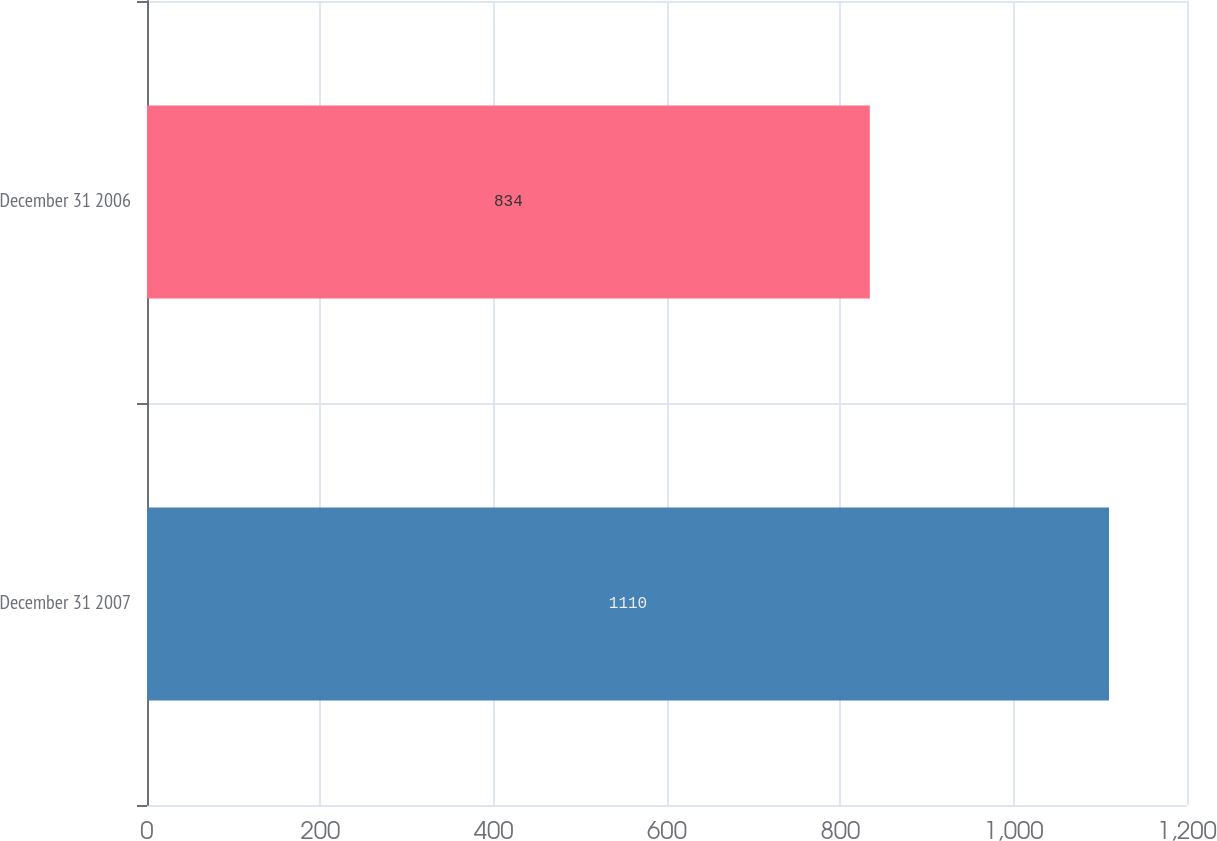<chart> <loc_0><loc_0><loc_500><loc_500><bar_chart><fcel>December 31 2007<fcel>December 31 2006<nl><fcel>1110<fcel>834<nl></chart> 